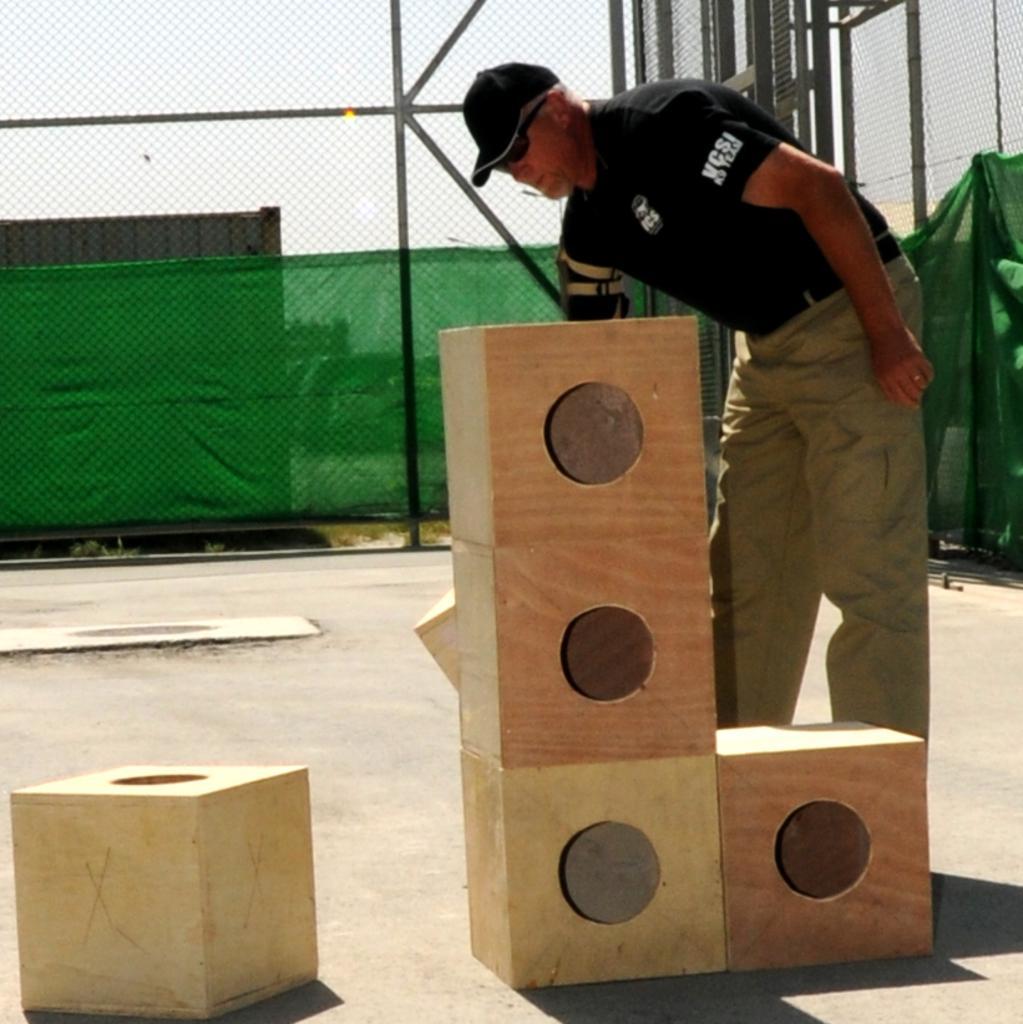Could you give a brief overview of what you see in this image? In this image I can see a person standing, the person is wearing black shirt, cream pant. In front I can see few blocks in cream and brown color, background I can see the railing, a cloth in green color and the sky is in white color. 